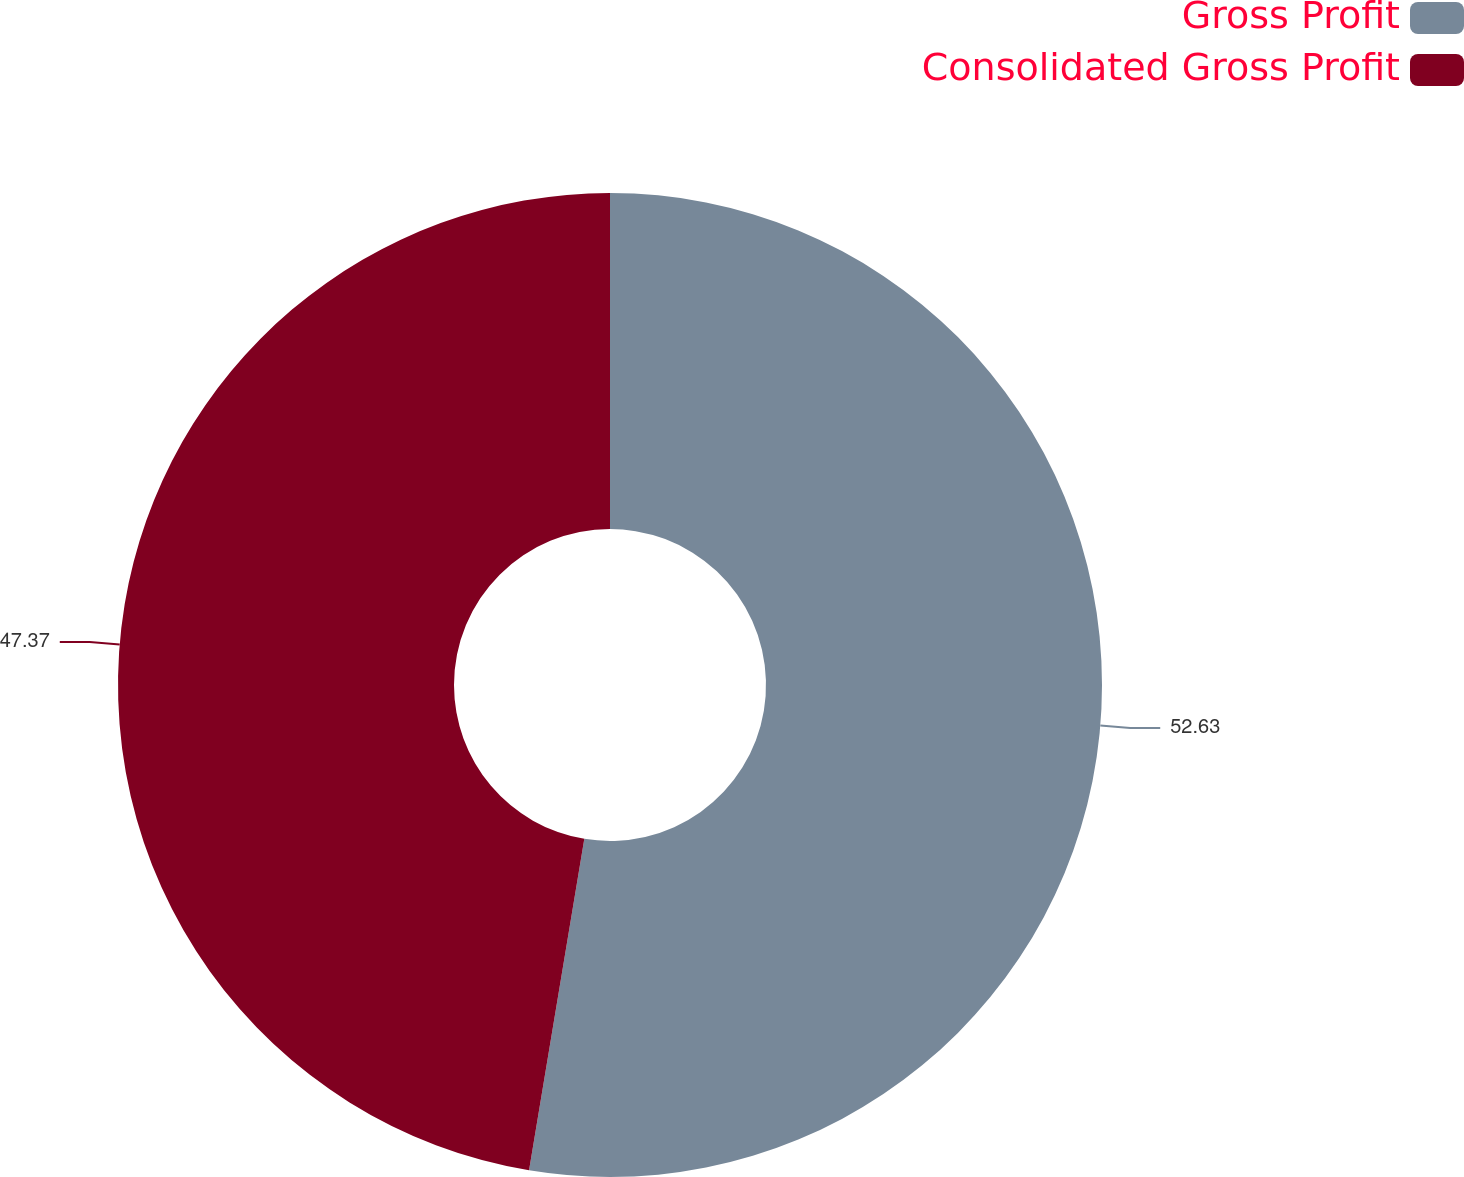Convert chart. <chart><loc_0><loc_0><loc_500><loc_500><pie_chart><fcel>Gross Profit<fcel>Consolidated Gross Profit<nl><fcel>52.63%<fcel>47.37%<nl></chart> 